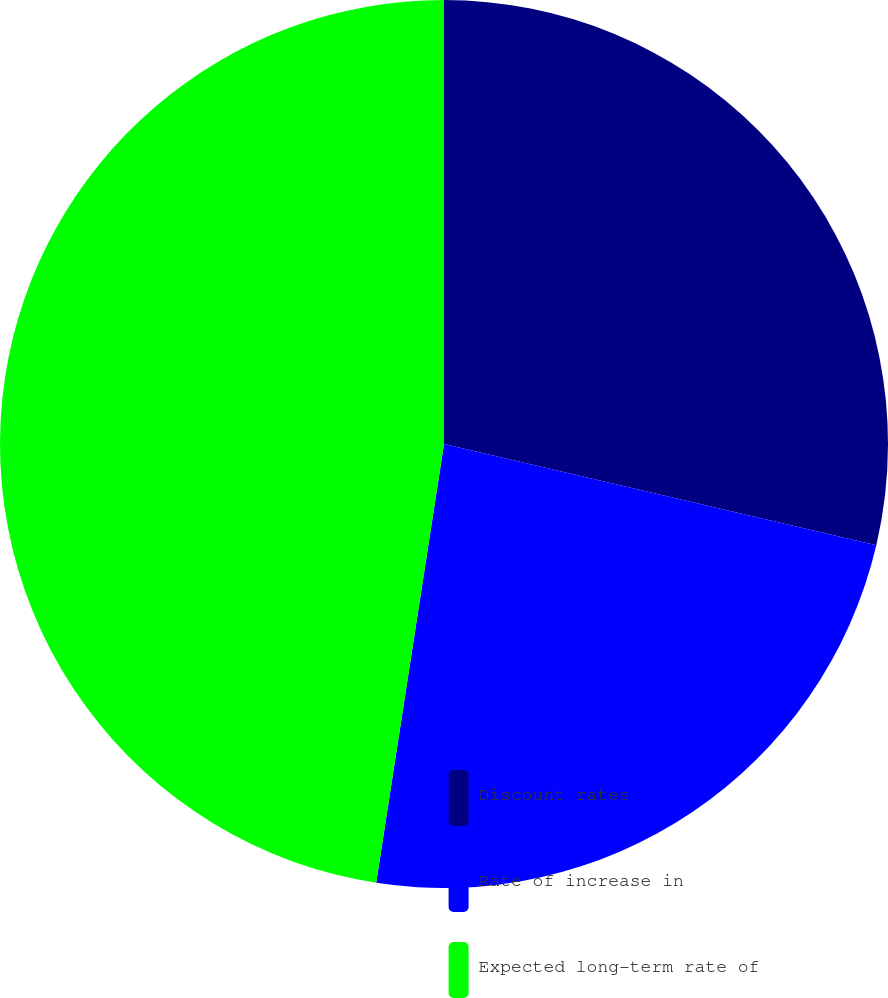Convert chart to OTSL. <chart><loc_0><loc_0><loc_500><loc_500><pie_chart><fcel>Discount rates<fcel>Rate of increase in<fcel>Expected long-term rate of<nl><fcel>28.66%<fcel>23.78%<fcel>47.56%<nl></chart> 